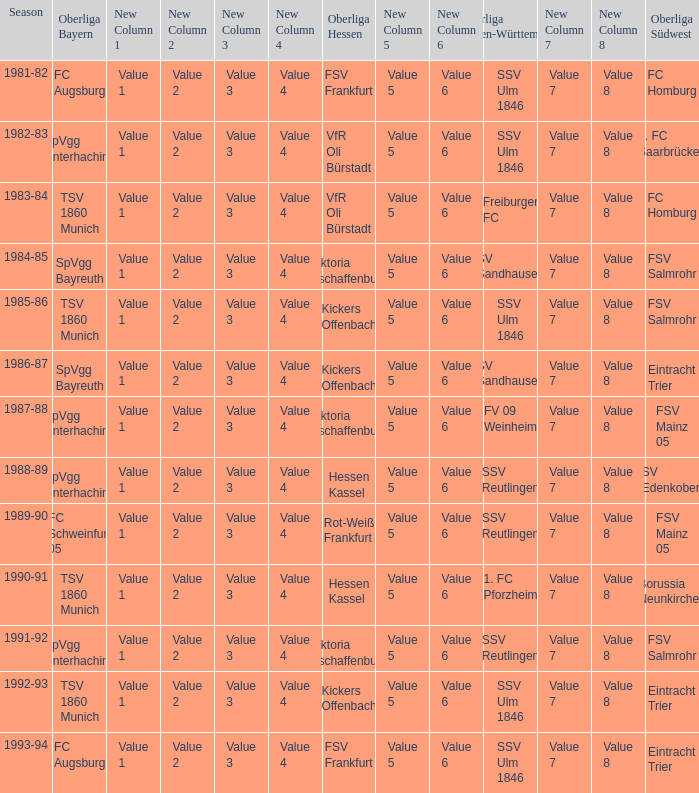Which Oberliga Bayern has a Season of 1981-82? FC Augsburg. 